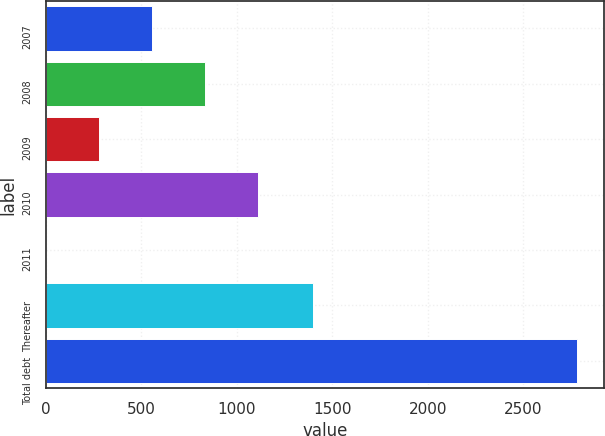Convert chart. <chart><loc_0><loc_0><loc_500><loc_500><bar_chart><fcel>2007<fcel>2008<fcel>2009<fcel>2010<fcel>2011<fcel>Thereafter<fcel>Total debt<nl><fcel>557<fcel>835<fcel>279<fcel>1113<fcel>1<fcel>1399<fcel>2781<nl></chart> 